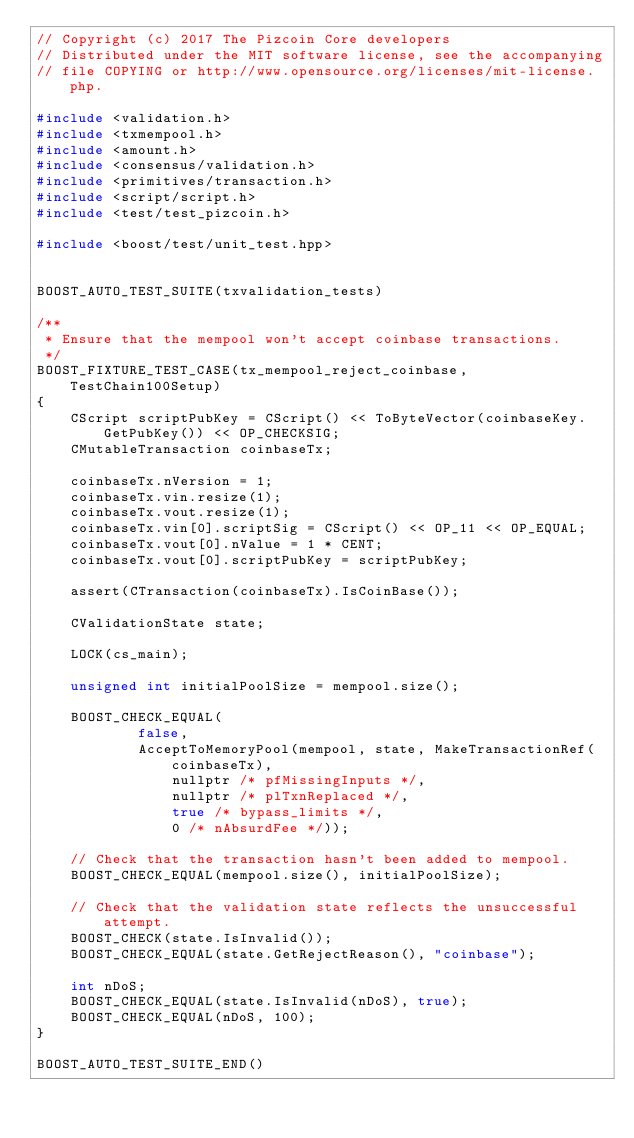Convert code to text. <code><loc_0><loc_0><loc_500><loc_500><_C++_>// Copyright (c) 2017 The Pizcoin Core developers
// Distributed under the MIT software license, see the accompanying
// file COPYING or http://www.opensource.org/licenses/mit-license.php.

#include <validation.h>
#include <txmempool.h>
#include <amount.h>
#include <consensus/validation.h>
#include <primitives/transaction.h>
#include <script/script.h>
#include <test/test_pizcoin.h>

#include <boost/test/unit_test.hpp>


BOOST_AUTO_TEST_SUITE(txvalidation_tests)

/**
 * Ensure that the mempool won't accept coinbase transactions.
 */
BOOST_FIXTURE_TEST_CASE(tx_mempool_reject_coinbase, TestChain100Setup)
{
    CScript scriptPubKey = CScript() << ToByteVector(coinbaseKey.GetPubKey()) << OP_CHECKSIG;
    CMutableTransaction coinbaseTx;

    coinbaseTx.nVersion = 1;
    coinbaseTx.vin.resize(1);
    coinbaseTx.vout.resize(1);
    coinbaseTx.vin[0].scriptSig = CScript() << OP_11 << OP_EQUAL;
    coinbaseTx.vout[0].nValue = 1 * CENT;
    coinbaseTx.vout[0].scriptPubKey = scriptPubKey;

    assert(CTransaction(coinbaseTx).IsCoinBase());

    CValidationState state;

    LOCK(cs_main);

    unsigned int initialPoolSize = mempool.size();

    BOOST_CHECK_EQUAL(
            false,
            AcceptToMemoryPool(mempool, state, MakeTransactionRef(coinbaseTx),
                nullptr /* pfMissingInputs */,
                nullptr /* plTxnReplaced */,
                true /* bypass_limits */,
                0 /* nAbsurdFee */));

    // Check that the transaction hasn't been added to mempool.
    BOOST_CHECK_EQUAL(mempool.size(), initialPoolSize);

    // Check that the validation state reflects the unsuccessful attempt.
    BOOST_CHECK(state.IsInvalid());
    BOOST_CHECK_EQUAL(state.GetRejectReason(), "coinbase");

    int nDoS;
    BOOST_CHECK_EQUAL(state.IsInvalid(nDoS), true);
    BOOST_CHECK_EQUAL(nDoS, 100);
}

BOOST_AUTO_TEST_SUITE_END()
</code> 